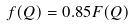Convert formula to latex. <formula><loc_0><loc_0><loc_500><loc_500>f ( Q ) = 0 . 8 5 F ( Q )</formula> 